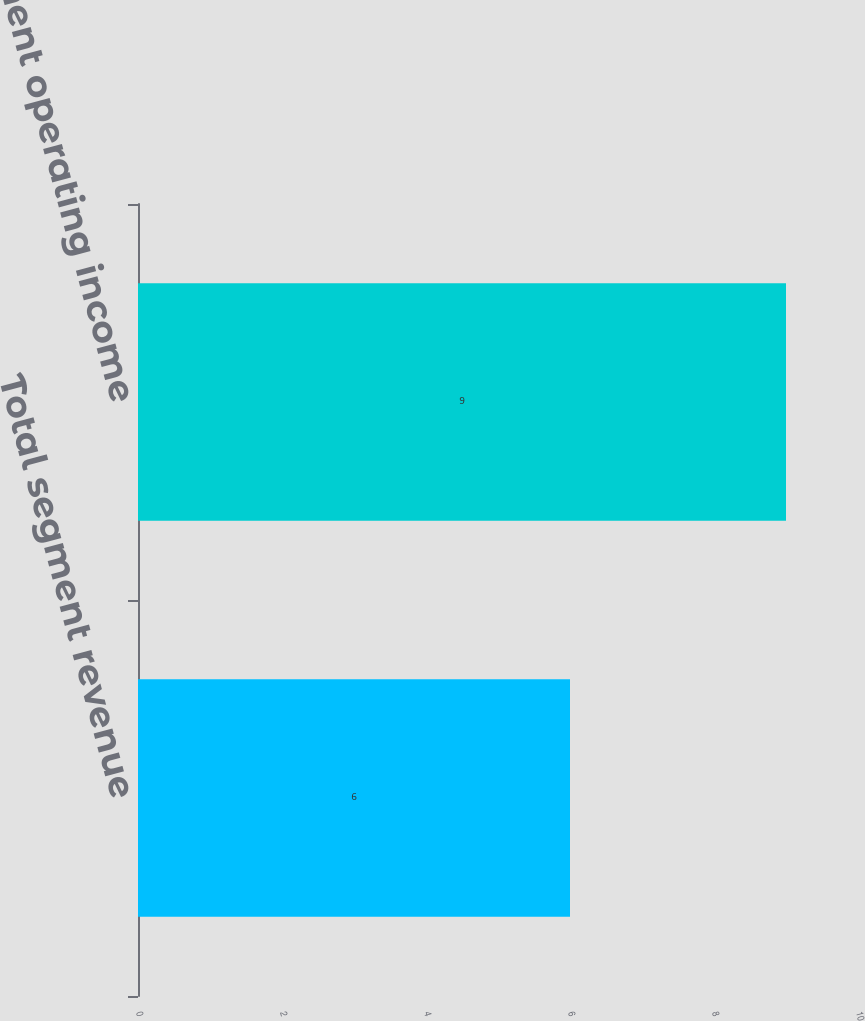Convert chart. <chart><loc_0><loc_0><loc_500><loc_500><bar_chart><fcel>Total segment revenue<fcel>Segment operating income<nl><fcel>6<fcel>9<nl></chart> 